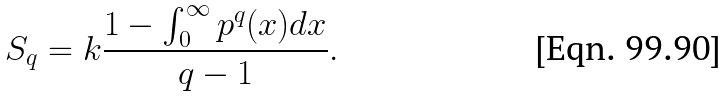Convert formula to latex. <formula><loc_0><loc_0><loc_500><loc_500>S _ { q } = k \frac { 1 - \int _ { 0 } ^ { \infty } p ^ { q } ( x ) d x } { q - 1 } .</formula> 